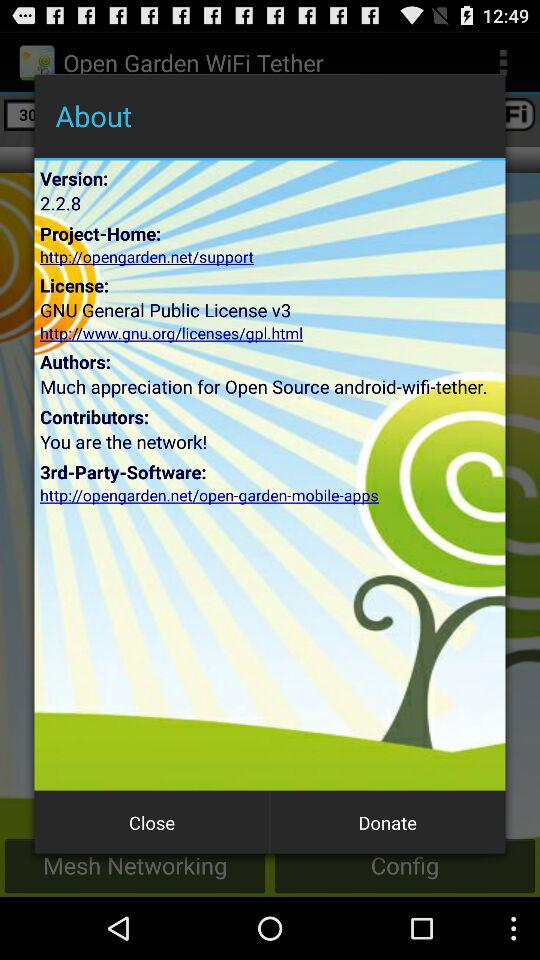What is the URL for 3rd-Party-Software? The URL is "http://opengarden.net/open-garden-mobille-apps". 